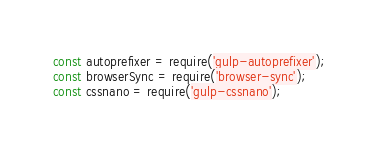Convert code to text. <code><loc_0><loc_0><loc_500><loc_500><_JavaScript_>const autoprefixer = require('gulp-autoprefixer');
const browserSync = require('browser-sync');
const cssnano = require('gulp-cssnano');</code> 